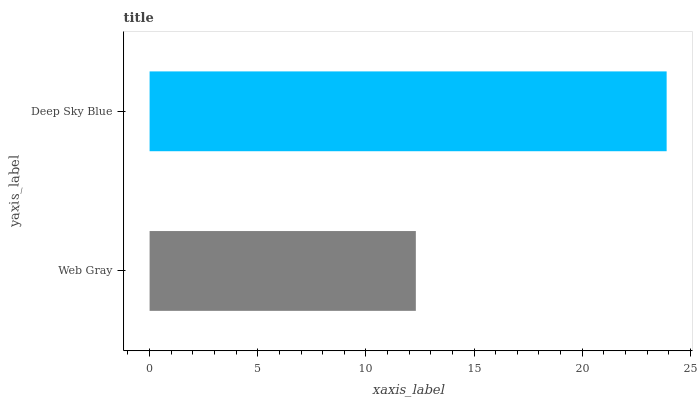Is Web Gray the minimum?
Answer yes or no. Yes. Is Deep Sky Blue the maximum?
Answer yes or no. Yes. Is Deep Sky Blue the minimum?
Answer yes or no. No. Is Deep Sky Blue greater than Web Gray?
Answer yes or no. Yes. Is Web Gray less than Deep Sky Blue?
Answer yes or no. Yes. Is Web Gray greater than Deep Sky Blue?
Answer yes or no. No. Is Deep Sky Blue less than Web Gray?
Answer yes or no. No. Is Deep Sky Blue the high median?
Answer yes or no. Yes. Is Web Gray the low median?
Answer yes or no. Yes. Is Web Gray the high median?
Answer yes or no. No. Is Deep Sky Blue the low median?
Answer yes or no. No. 